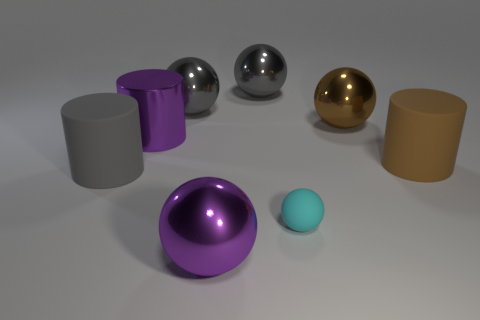What shape is the large shiny object that is the same color as the shiny cylinder?
Your response must be concise. Sphere. There is a purple shiny object that is the same shape as the small cyan matte object; what size is it?
Provide a short and direct response. Large. What number of large gray objects are the same material as the big gray cylinder?
Provide a succinct answer. 0. What material is the small cyan object?
Your response must be concise. Rubber. The large purple object on the right side of the large cylinder behind the brown cylinder is what shape?
Provide a short and direct response. Sphere. What is the shape of the matte thing on the right side of the tiny thing?
Give a very brief answer. Cylinder. What number of tiny matte objects have the same color as the big metal cylinder?
Keep it short and to the point. 0. What color is the matte ball?
Your answer should be very brief. Cyan. There is a matte object that is in front of the gray matte object; what number of matte things are behind it?
Keep it short and to the point. 2. There is a brown shiny ball; is it the same size as the rubber object that is on the left side of the large purple metallic cylinder?
Give a very brief answer. Yes. 